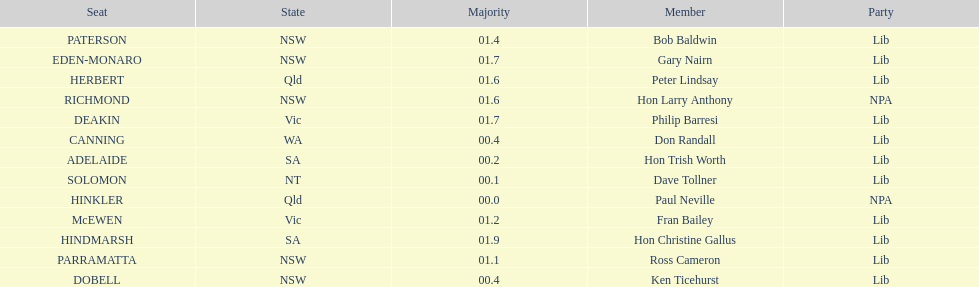Was fran bailey from vic or wa? Vic. 